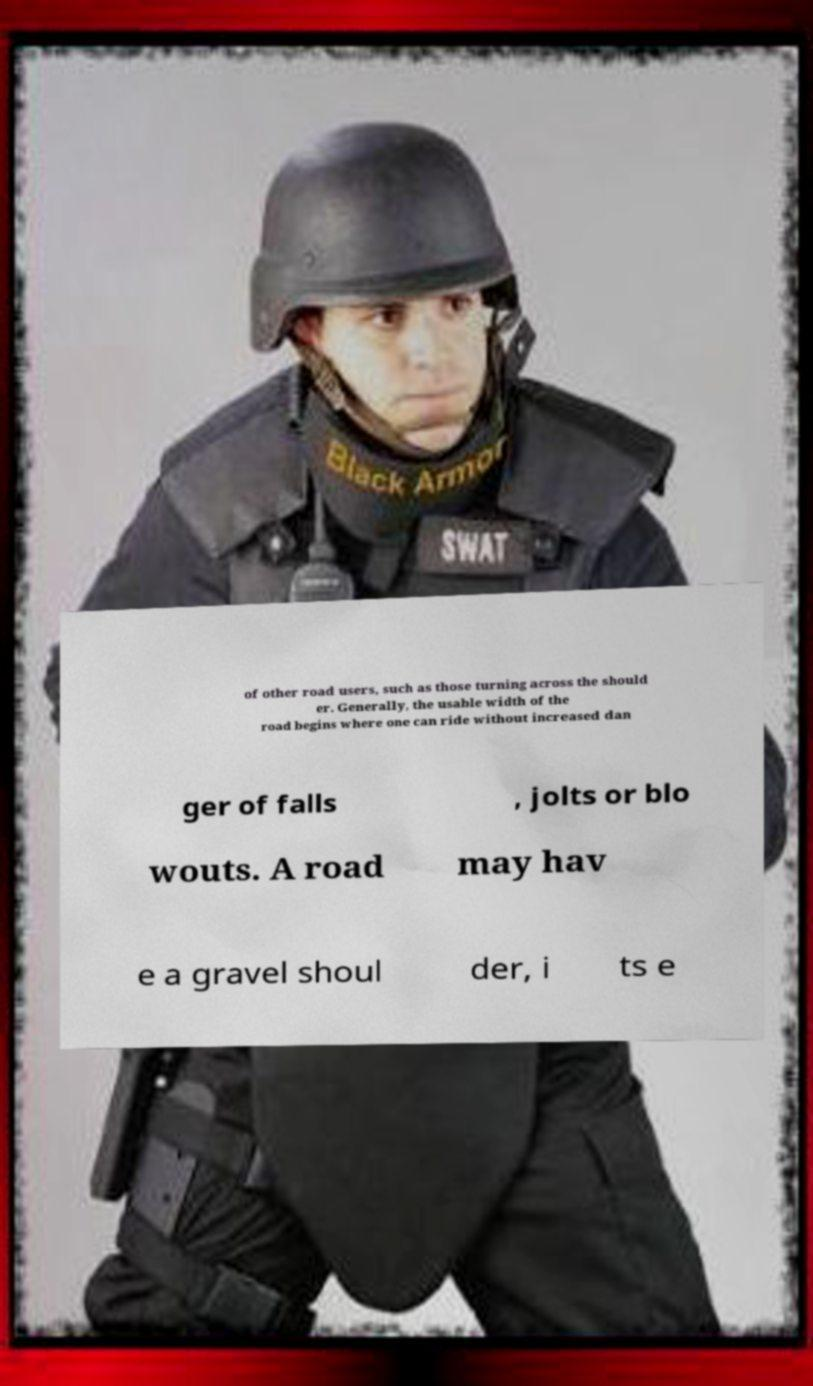Can you read and provide the text displayed in the image?This photo seems to have some interesting text. Can you extract and type it out for me? of other road users, such as those turning across the should er. Generally, the usable width of the road begins where one can ride without increased dan ger of falls , jolts or blo wouts. A road may hav e a gravel shoul der, i ts e 